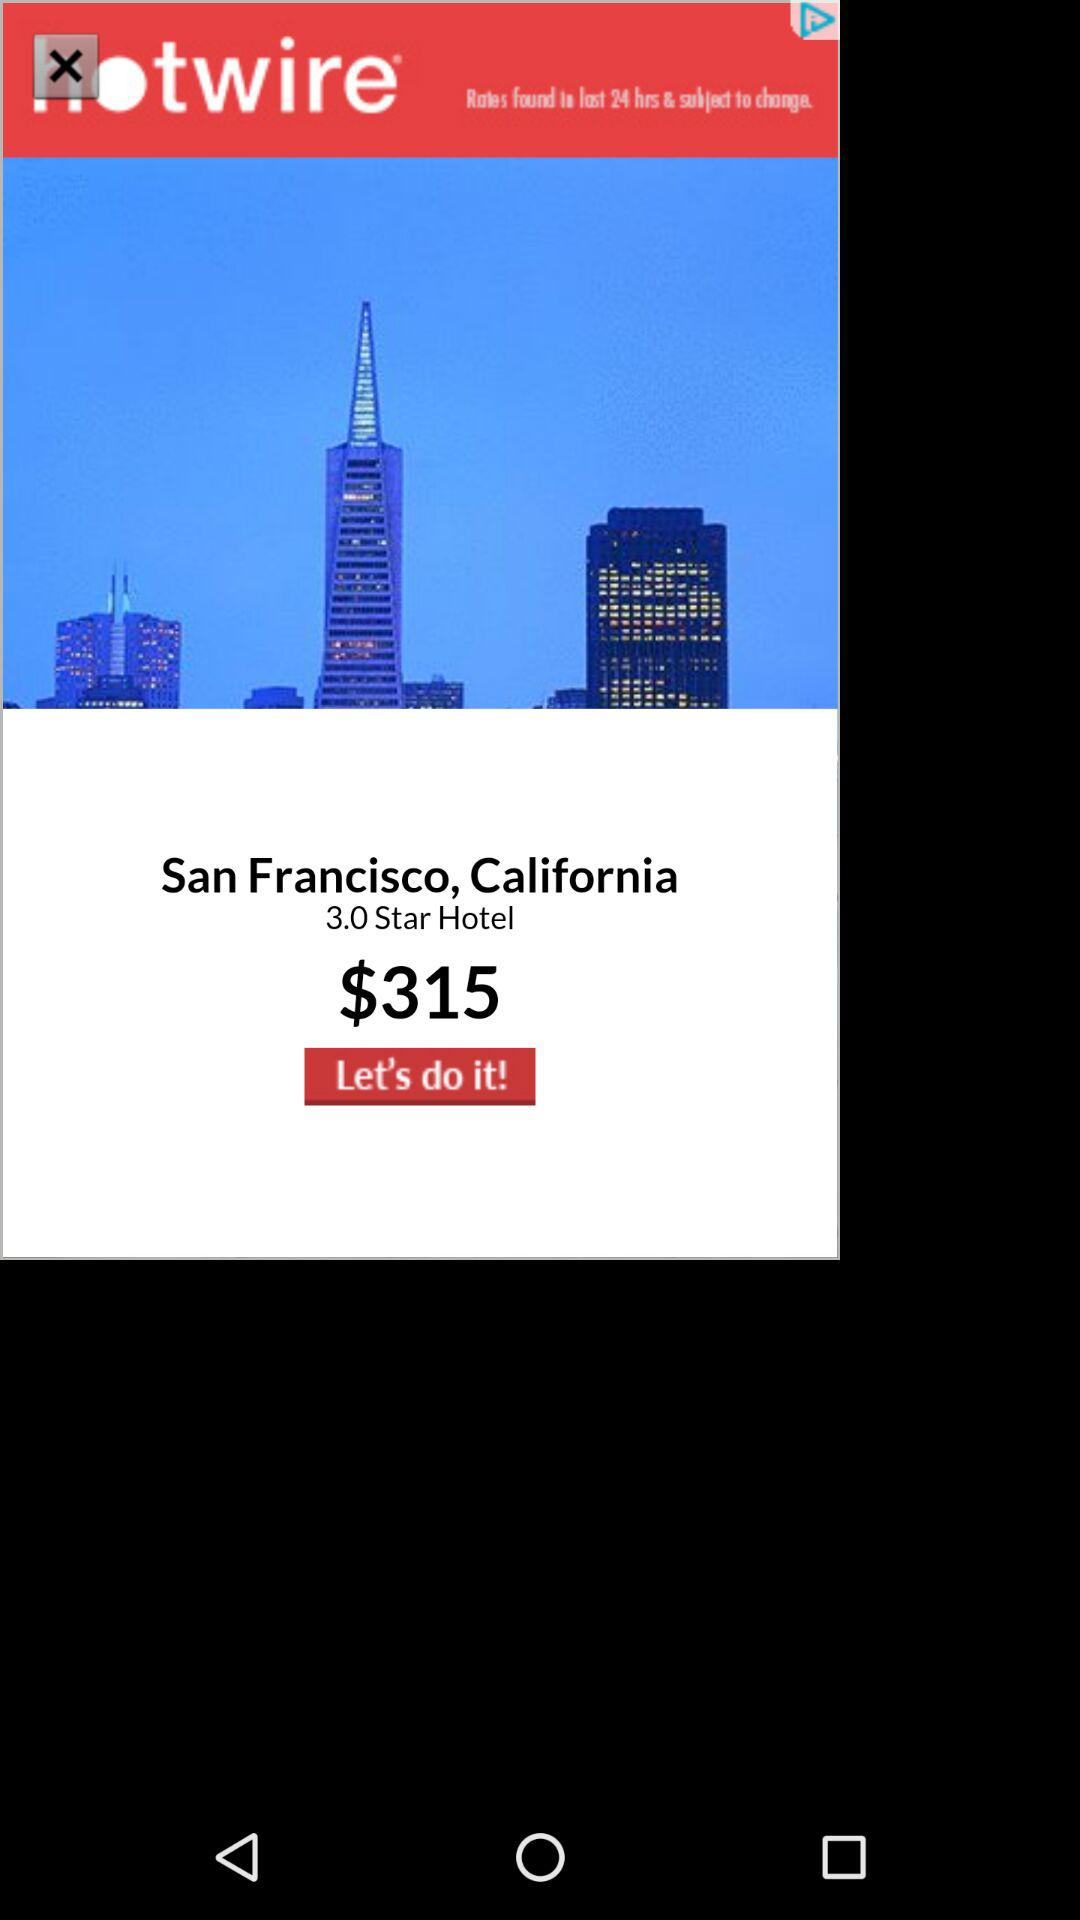How much is the hotel per night?
Answer the question using a single word or phrase. $315 